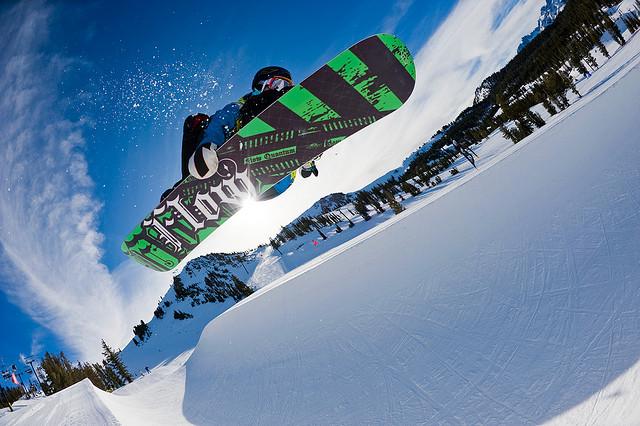Is this a clear day?
Answer briefly. Yes. What is the man doing?
Quick response, please. Snowboarding. Is it summer?
Short answer required. No. 